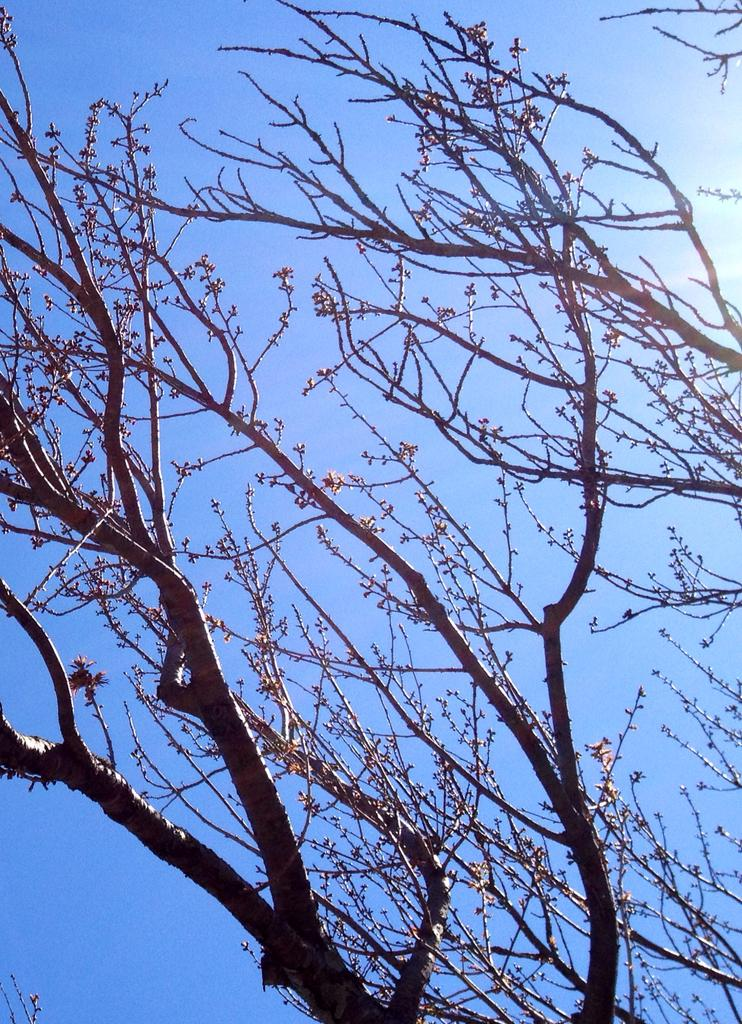What type of vegetation is visible in the image? There are trees in front of the image. What part of the natural environment can be seen in the image? The sky is visible in the background of the image. What is the condition of the sky in the image? The sky is clear in the image. Can you read the letter that is hanging from the tree in the image? There is no letter hanging from the tree in the image; only trees and the sky are present. What type of crate is visible in the image? There is no crate present in the image. 